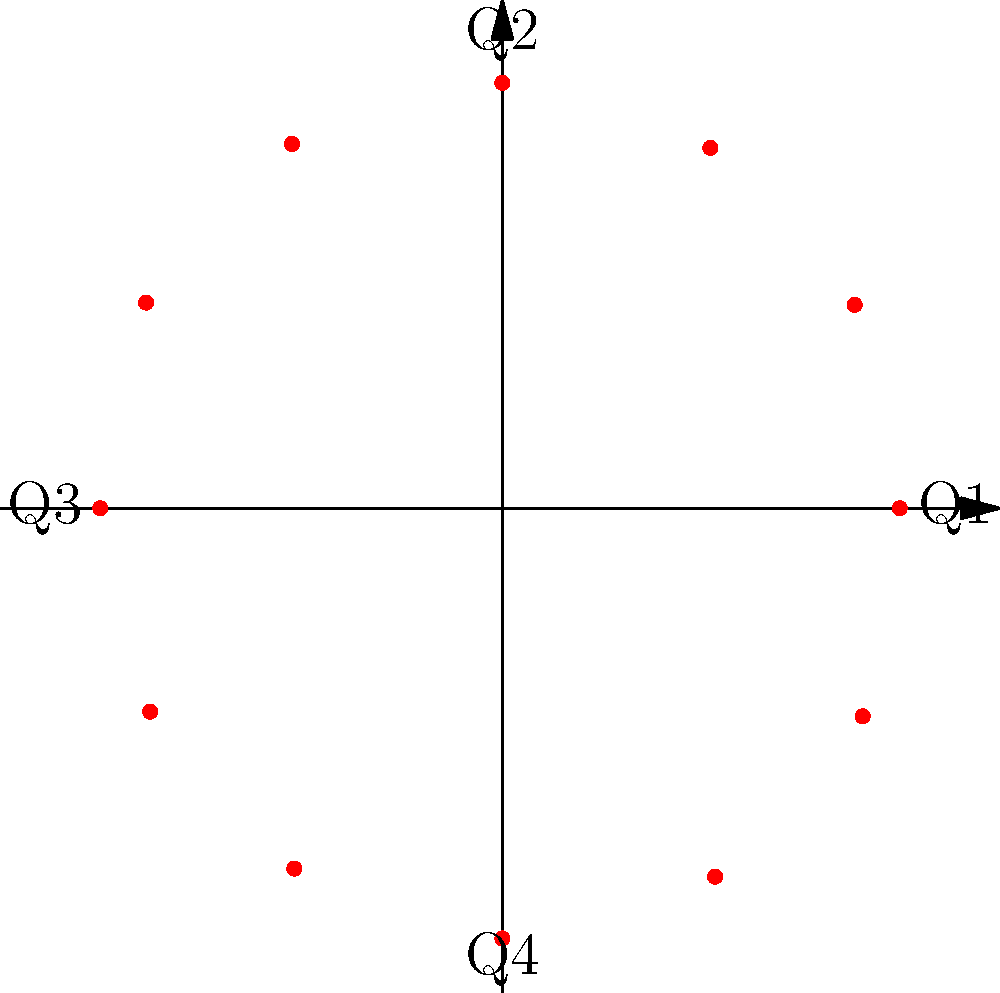In the polar coordinate plot of customer satisfaction scores over the past year, which quarter shows the highest satisfaction score, and what strategic insight can be drawn from this pattern for improving customer experience in financial services? To answer this question, let's analyze the polar coordinate plot step-by-step:

1. The plot represents customer satisfaction scores over a year, with each point corresponding to a month.

2. The radial distance from the center represents the satisfaction score, while the angle represents the time of the year.

3. The plot is divided into four quadrants, representing the four quarters of the year (Q1, Q2, Q3, Q4).

4. To determine the highest satisfaction score, we need to identify the point furthest from the center in each quarter:

   Q1 (0° to 90°): Highest point is at about 90° (9.1)
   Q2 (90° to 180°): Highest point is at about 120° (9.0)
   Q3 (180° to 270°): Highest point is at about 270° (9.2)
   Q4 (270° to 360°): Highest point is at about 300° (9.1)

5. The highest overall score is in Q3, specifically at the 270° mark (9.2).

6. Strategic insight: The peak in Q3 (typically July-September) could indicate higher satisfaction during summer months. This might be due to:
   - Reduced financial stress during vacation season
   - Successful marketing campaigns or product launches timed for this period
   - Improved service delivery after mid-year reviews and adjustments

7. To improve customer experience, financial services could:
   - Analyze factors contributing to the Q3 peak and apply these insights year-round
   - Develop strategies to maintain high satisfaction levels in other quarters
   - Focus on enhancing services or launching initiatives in lower-scoring periods to balance satisfaction throughout the year
Answer: Q3; leverage summer peak factors year-round and enhance lower-scoring periods. 